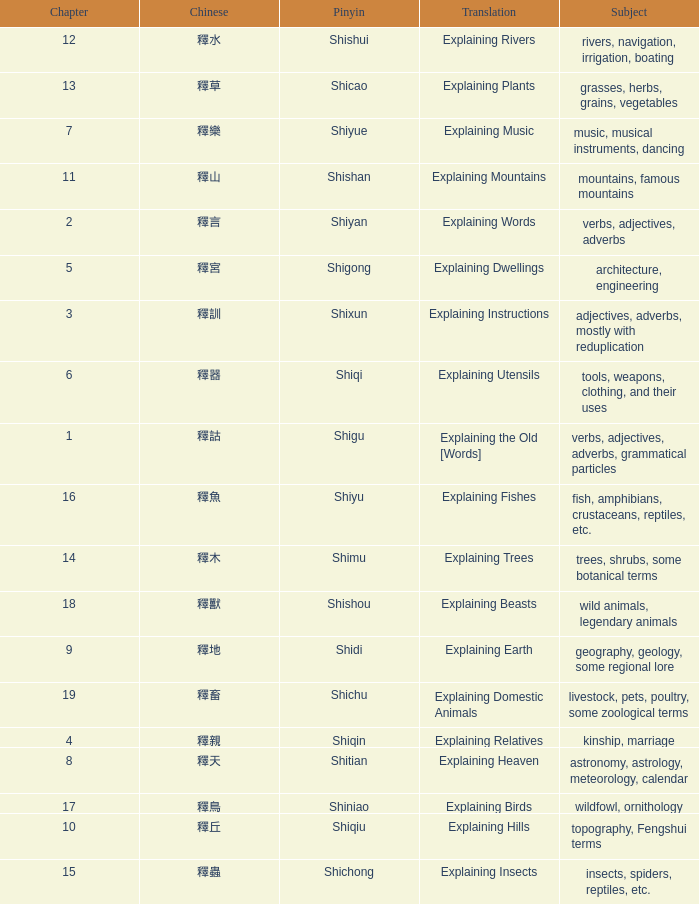Name the total number of chapter for chinese of 釋宮 1.0. 